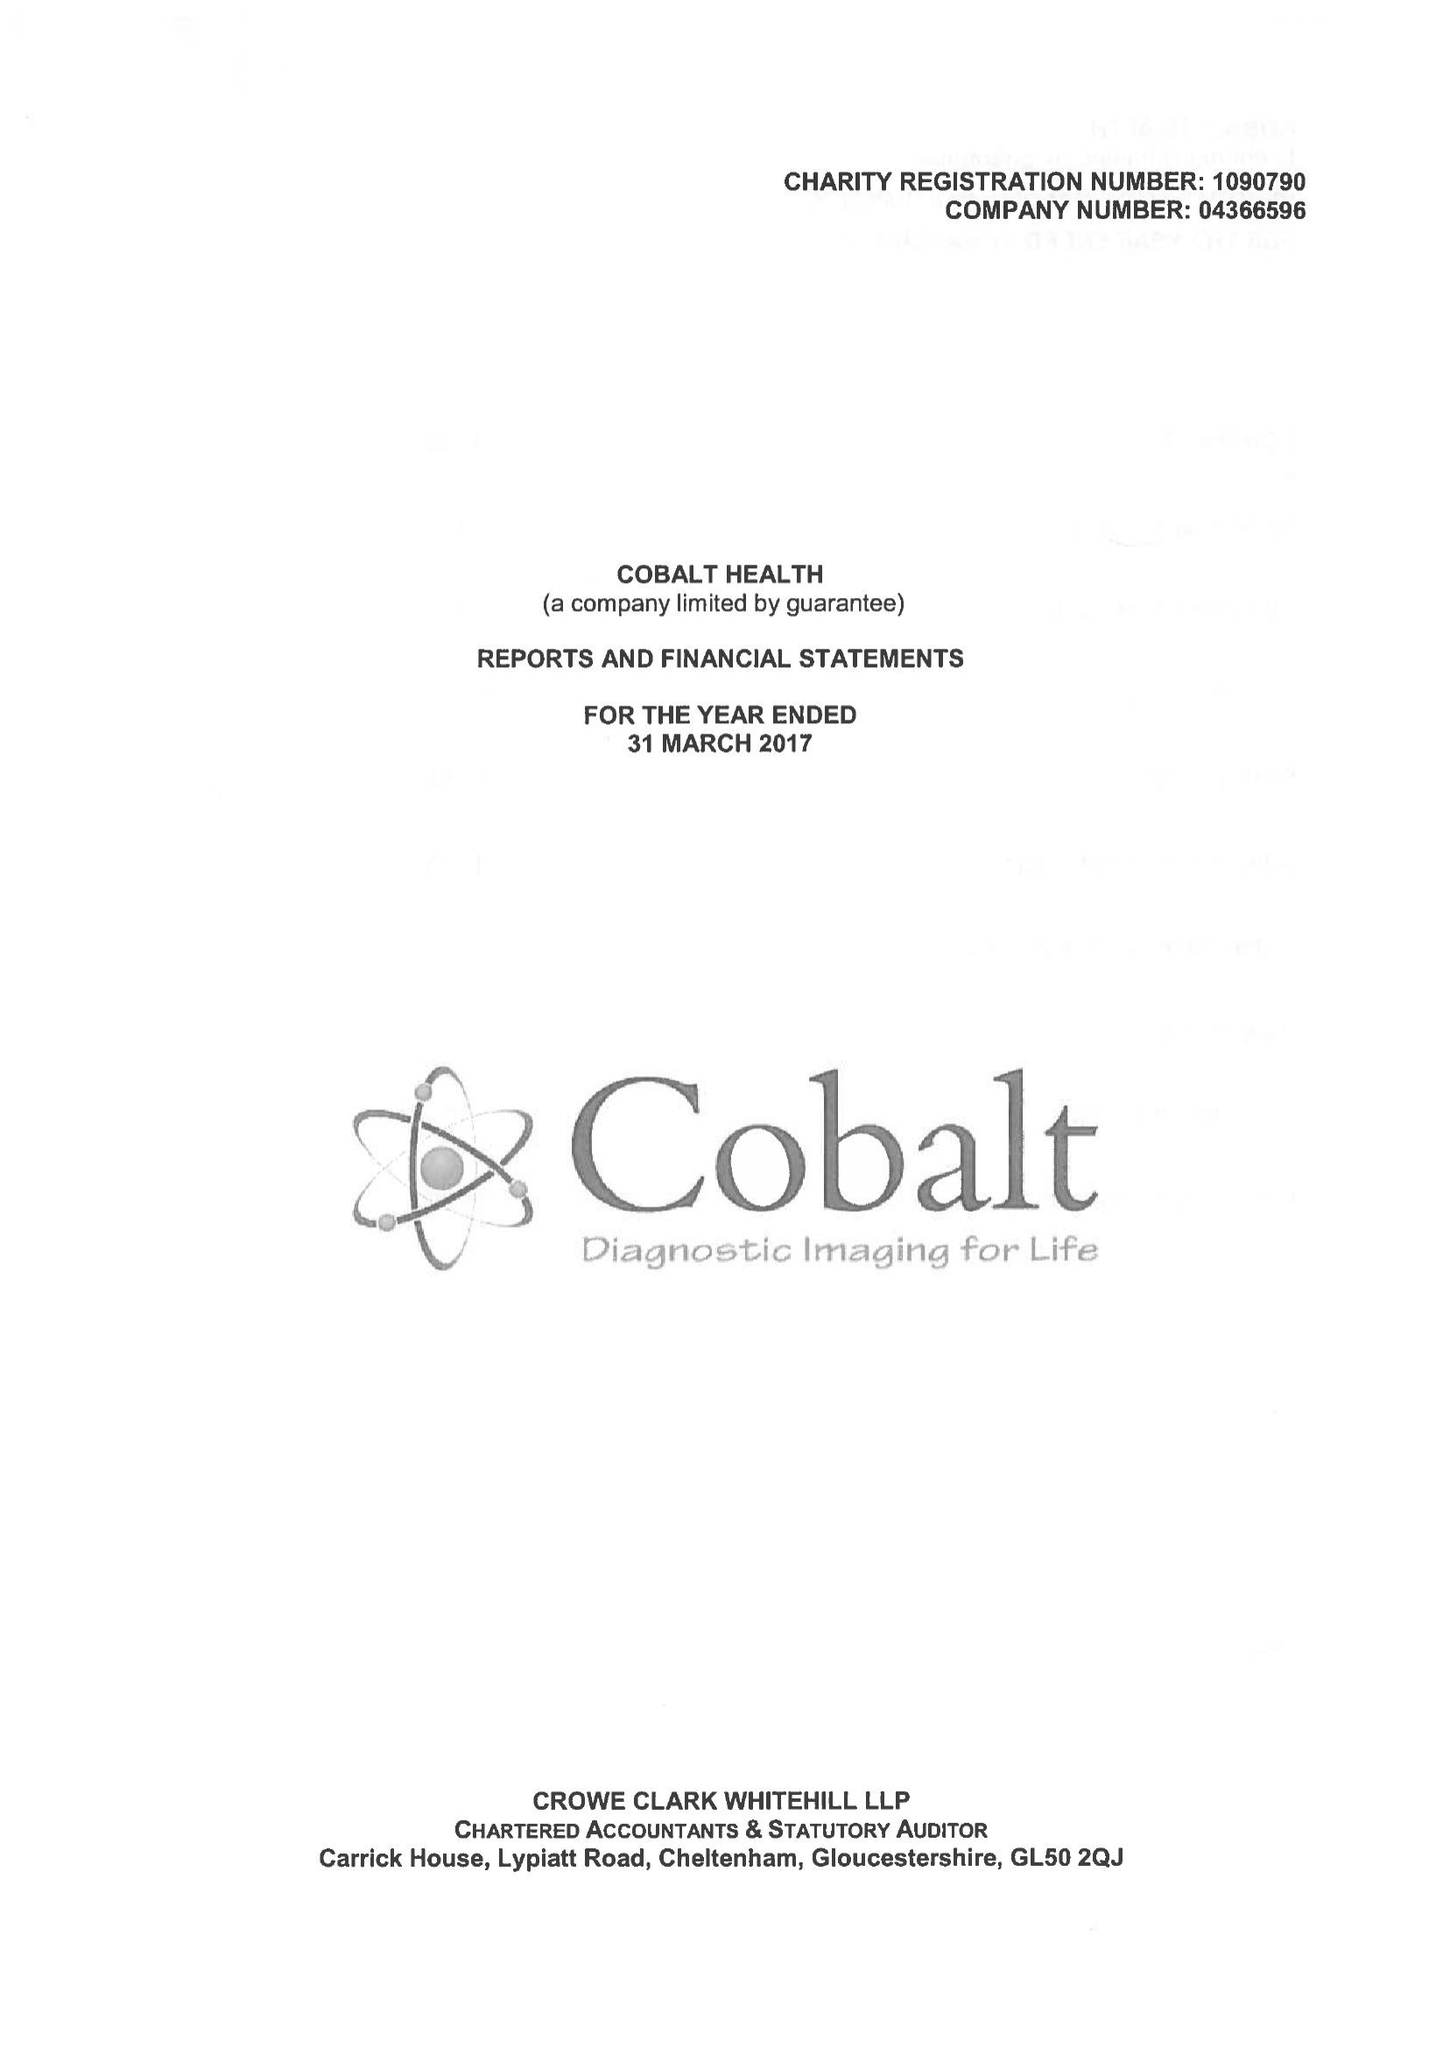What is the value for the income_annually_in_british_pounds?
Answer the question using a single word or phrase. 9839733.00 